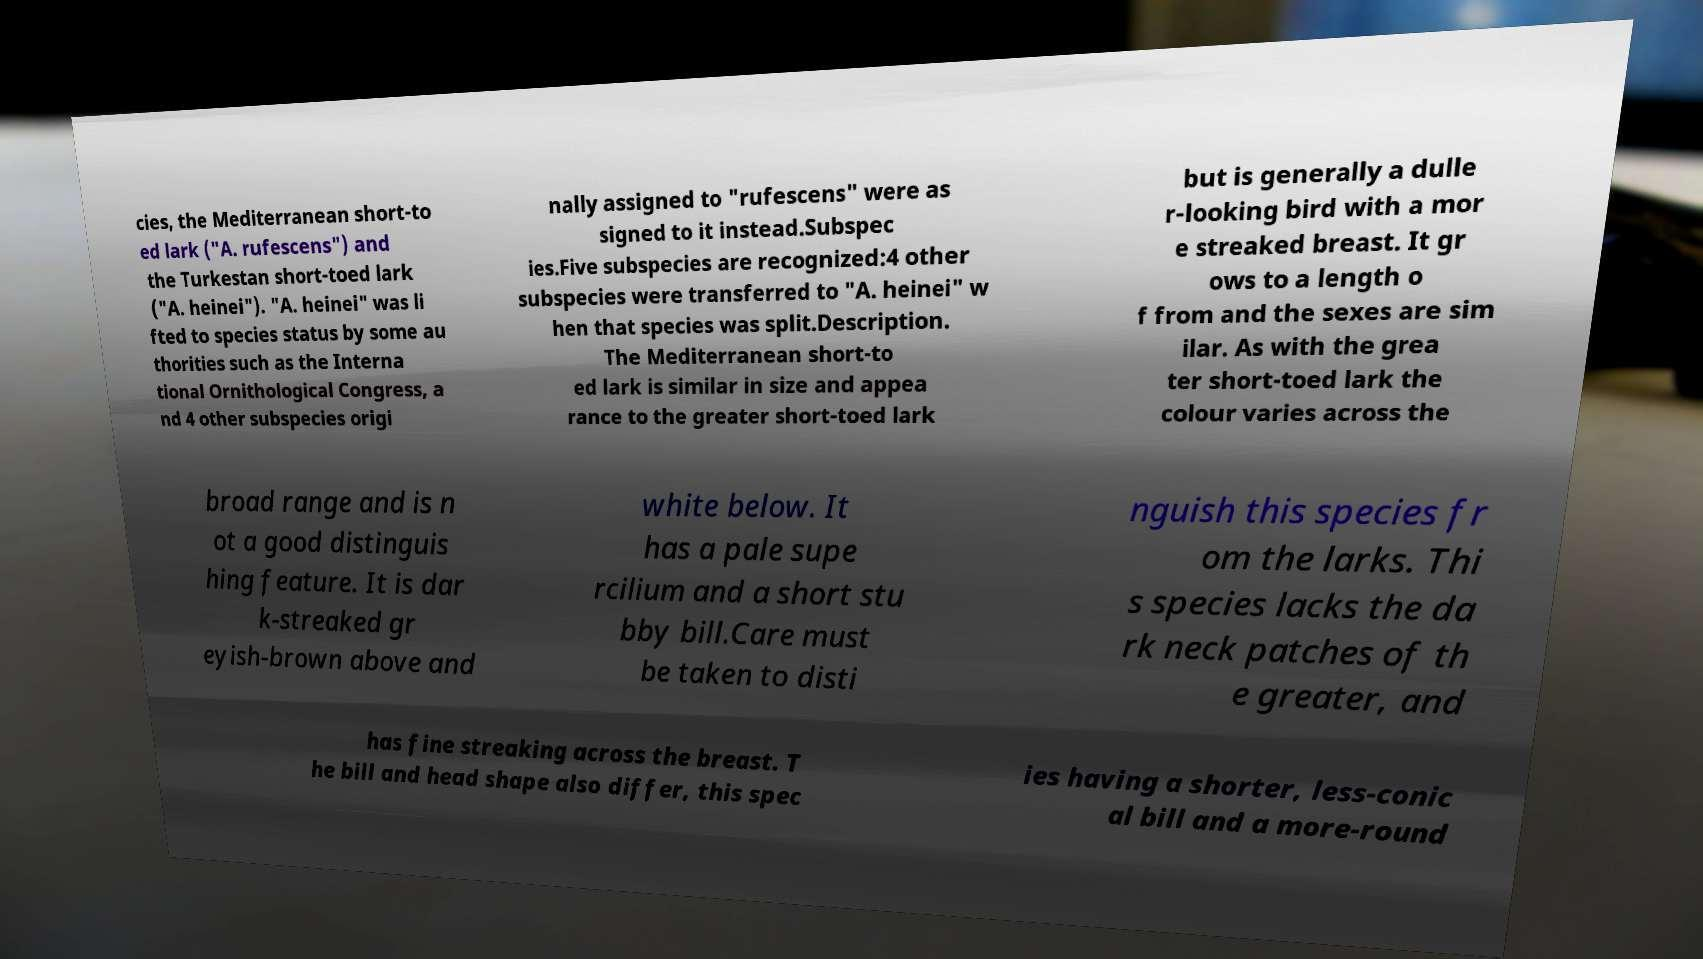Please identify and transcribe the text found in this image. cies, the Mediterranean short-to ed lark ("A. rufescens") and the Turkestan short-toed lark ("A. heinei"). "A. heinei" was li fted to species status by some au thorities such as the Interna tional Ornithological Congress, a nd 4 other subspecies origi nally assigned to "rufescens" were as signed to it instead.Subspec ies.Five subspecies are recognized:4 other subspecies were transferred to "A. heinei" w hen that species was split.Description. The Mediterranean short-to ed lark is similar in size and appea rance to the greater short-toed lark but is generally a dulle r-looking bird with a mor e streaked breast. It gr ows to a length o f from and the sexes are sim ilar. As with the grea ter short-toed lark the colour varies across the broad range and is n ot a good distinguis hing feature. It is dar k-streaked gr eyish-brown above and white below. It has a pale supe rcilium and a short stu bby bill.Care must be taken to disti nguish this species fr om the larks. Thi s species lacks the da rk neck patches of th e greater, and has fine streaking across the breast. T he bill and head shape also differ, this spec ies having a shorter, less-conic al bill and a more-round 